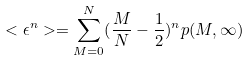<formula> <loc_0><loc_0><loc_500><loc_500>< \epsilon ^ { n } > = \sum _ { M = 0 } ^ { N } ( \frac { M } { N } - \frac { 1 } { 2 } ) ^ { n } p ( M , \infty )</formula> 